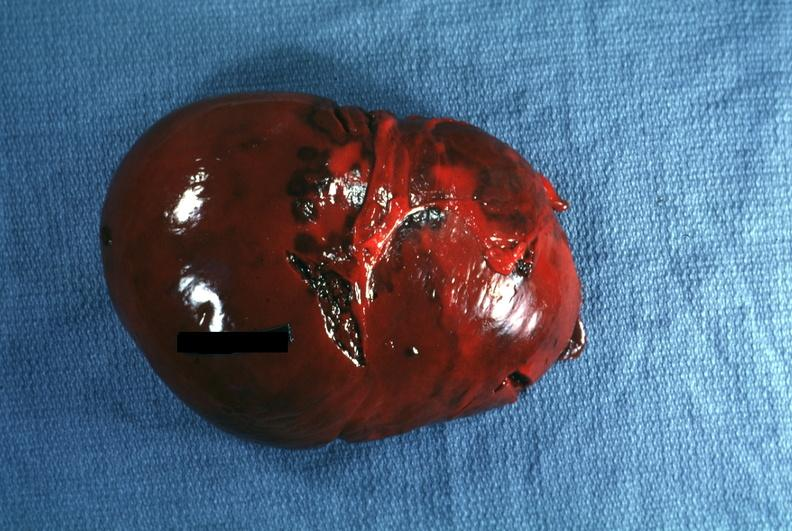what is present?
Answer the question using a single word or phrase. Spleen 